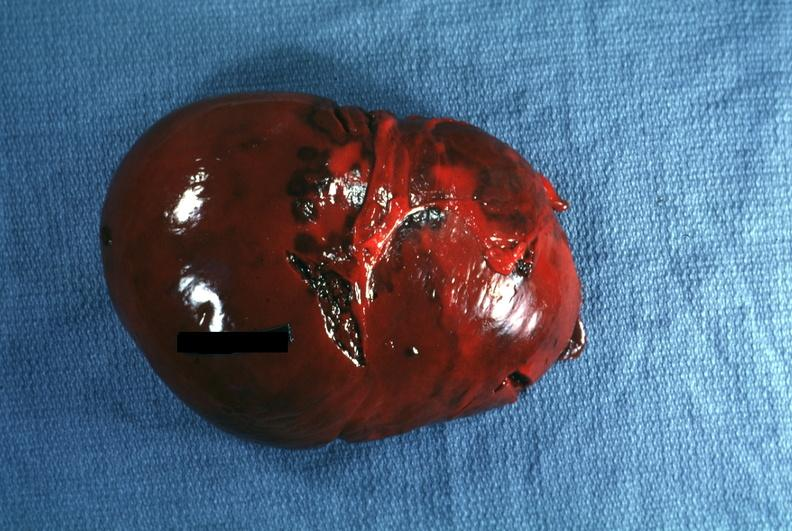what is present?
Answer the question using a single word or phrase. Spleen 